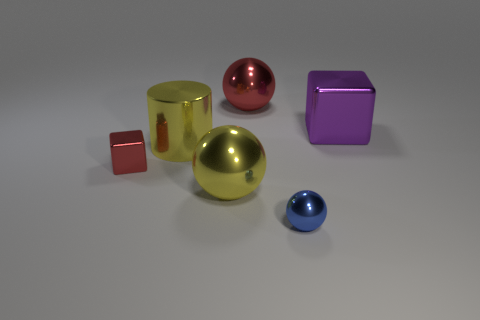There is a metal cube that is on the left side of the tiny object to the right of the metal cube in front of the purple metallic cube; what is its color?
Your answer should be very brief. Red. What number of other objects are there of the same color as the tiny sphere?
Keep it short and to the point. 0. Are there fewer yellow things than objects?
Make the answer very short. Yes. The metal object that is both to the right of the big red ball and in front of the purple thing is what color?
Provide a succinct answer. Blue. There is a yellow thing that is the same shape as the large red object; what is its material?
Offer a terse response. Metal. Are there more big blocks than metal balls?
Your response must be concise. No. What size is the thing that is both on the right side of the red shiny sphere and left of the purple object?
Provide a short and direct response. Small. What is the shape of the purple shiny thing?
Offer a terse response. Cube. What number of small red things are the same shape as the large purple object?
Provide a short and direct response. 1. Are there fewer small red cubes that are behind the large cylinder than blue shiny objects that are behind the tiny metallic block?
Make the answer very short. No. 